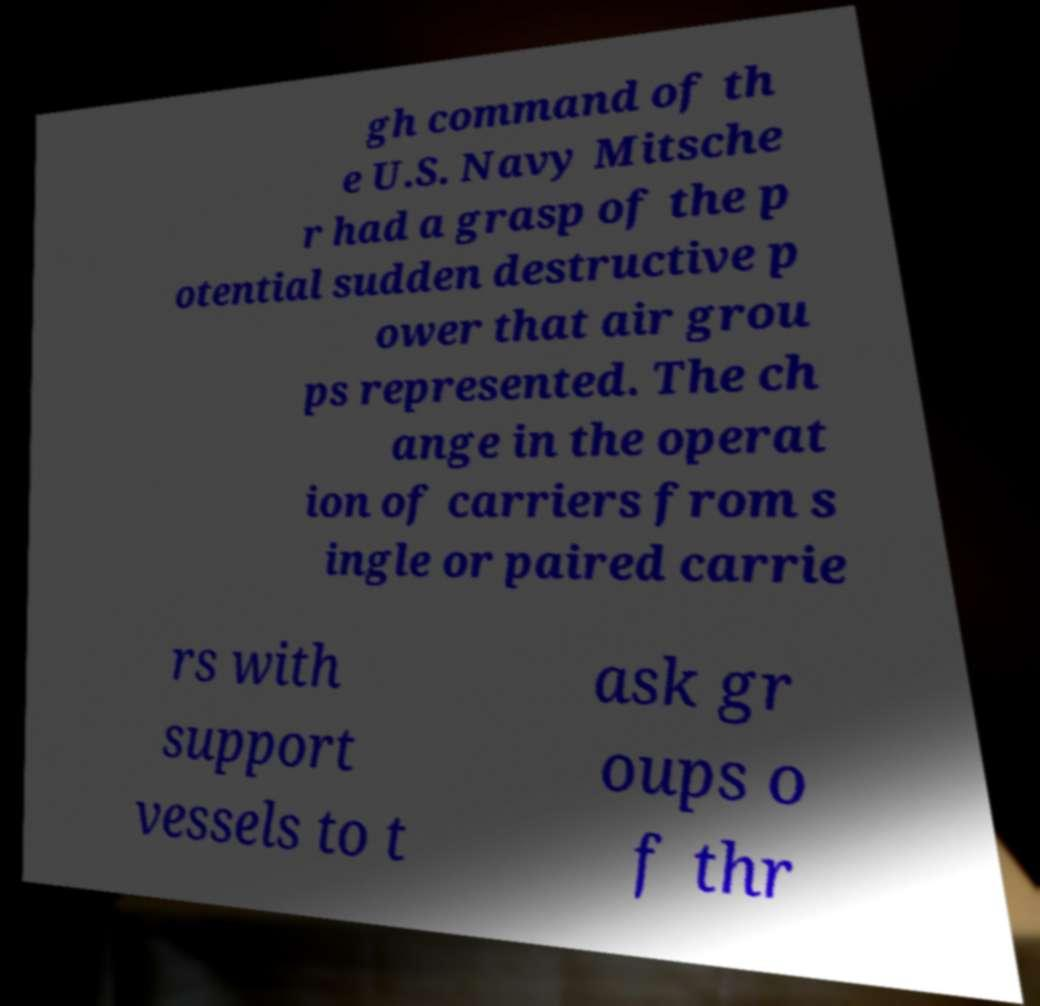For documentation purposes, I need the text within this image transcribed. Could you provide that? gh command of th e U.S. Navy Mitsche r had a grasp of the p otential sudden destructive p ower that air grou ps represented. The ch ange in the operat ion of carriers from s ingle or paired carrie rs with support vessels to t ask gr oups o f thr 